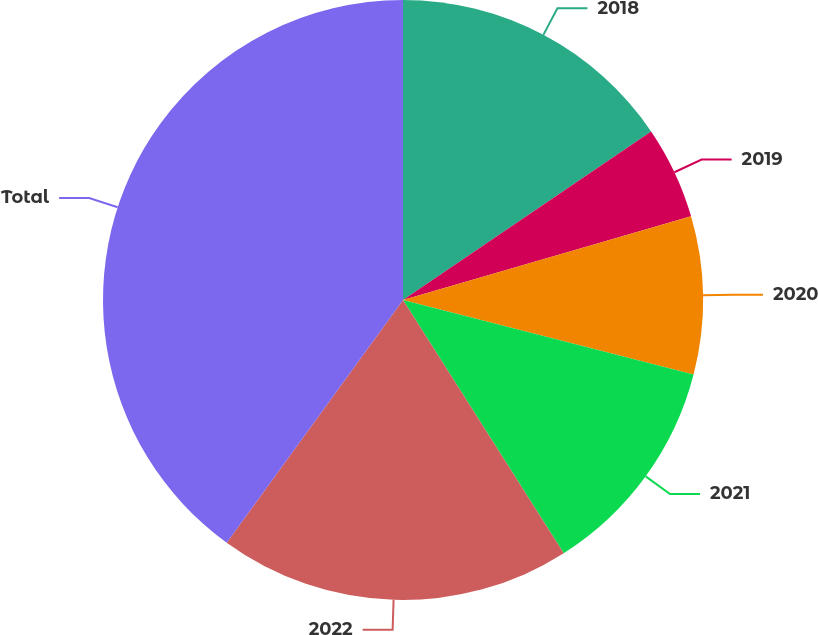Convert chart. <chart><loc_0><loc_0><loc_500><loc_500><pie_chart><fcel>2018<fcel>2019<fcel>2020<fcel>2021<fcel>2022<fcel>Total<nl><fcel>15.5%<fcel>5.0%<fcel>8.5%<fcel>12.0%<fcel>19.0%<fcel>40.0%<nl></chart> 